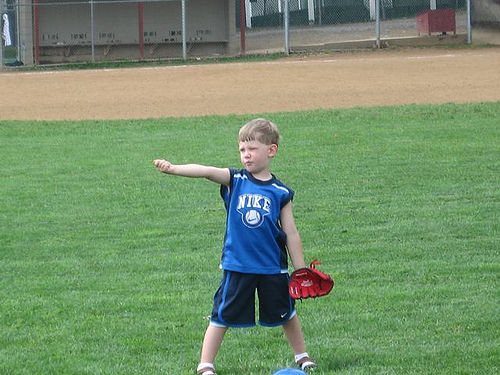Please provide the bounding box coordinate of the region this sentence describes: legs of the boy. [0.33, 0.77, 0.66, 0.81] Please provide the bounding box coordinate of the region this sentence describes: mitt on the hand. [0.59, 0.62, 0.68, 0.71] Please provide the bounding box coordinate of the region this sentence describes: a red baseball mit. [0.58, 0.65, 0.67, 0.73] Please provide a short description for this region: [0.58, 0.66, 0.66, 0.72]. The boy is wearing a red glove. Please provide a short description for this region: [0.44, 0.47, 0.58, 0.67]. The boy is wearing a blue shirt. Please provide a short description for this region: [0.07, 0.19, 0.46, 0.24]. A bench in the dugout. Please provide the bounding box coordinate of the region this sentence describes: The boys hair is blonde. [0.48, 0.35, 0.6, 0.44] Please provide the bounding box coordinate of the region this sentence describes: The baseball glove is small. [0.57, 0.61, 0.74, 0.77] Please provide the bounding box coordinate of the region this sentence describes: the boy's arm. [0.3, 0.44, 0.46, 0.49] Please provide a short description for this region: [0.03, 0.12, 0.97, 0.25]. A metal chain link fence. 